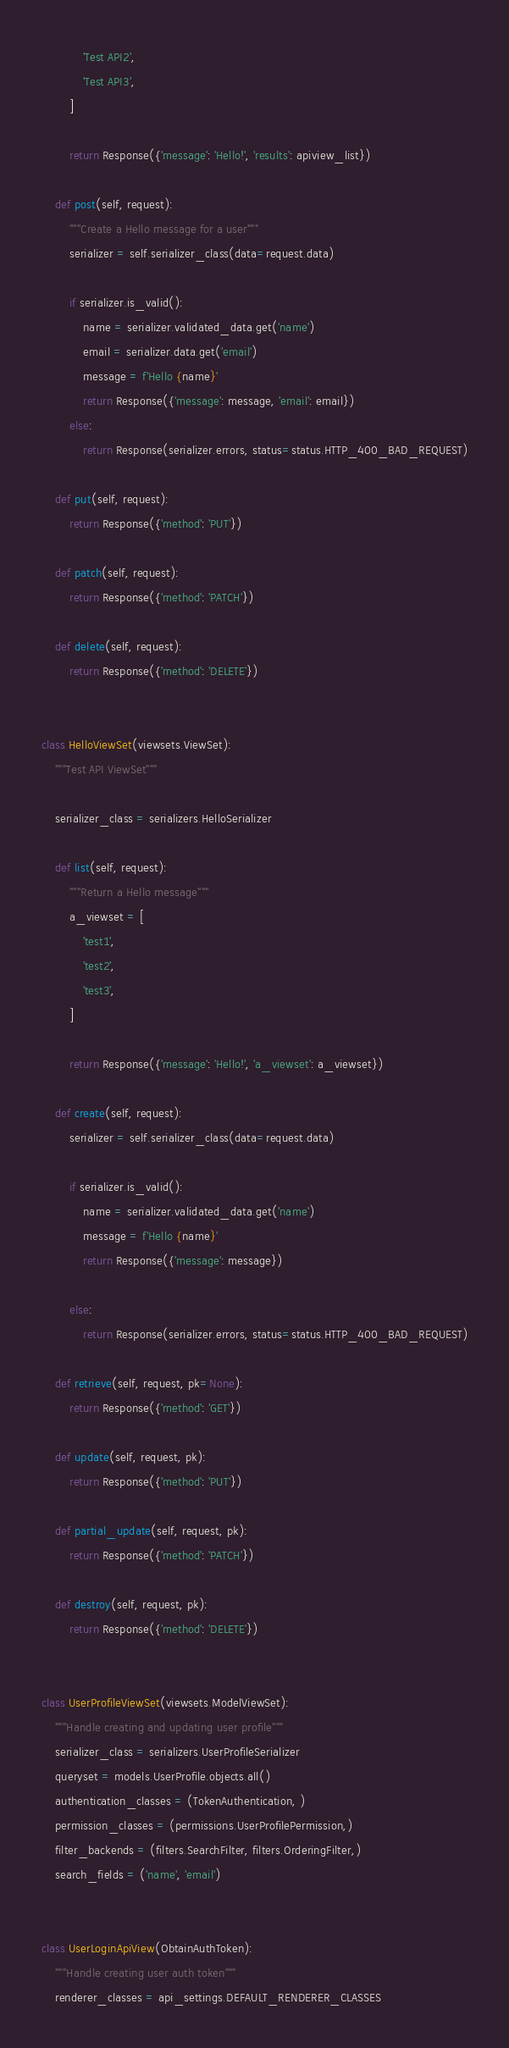<code> <loc_0><loc_0><loc_500><loc_500><_Python_>            'Test API2',
            'Test API3',
        ]

        return Response({'message': 'Hello!', 'results': apiview_list})

    def post(self, request):
        """Create a Hello message for a user"""
        serializer = self.serializer_class(data=request.data)

        if serializer.is_valid():
            name = serializer.validated_data.get('name')
            email = serializer.data.get('email')
            message = f'Hello {name}'
            return Response({'message': message, 'email': email})
        else:
            return Response(serializer.errors, status=status.HTTP_400_BAD_REQUEST)
    
    def put(self, request):
        return Response({'method': 'PUT'})

    def patch(self, request):
        return Response({'method': 'PATCH'})

    def delete(self, request):
        return Response({'method': 'DELETE'})
        

class HelloViewSet(viewsets.ViewSet):
    """Test API ViewSet"""

    serializer_class = serializers.HelloSerializer

    def list(self, request):
        """Return a Hello message"""
        a_viewset = [
            'test1',
            'test2',
            'test3',
        ]

        return Response({'message': 'Hello!', 'a_viewset': a_viewset})
    
    def create(self, request):
        serializer = self.serializer_class(data=request.data)

        if serializer.is_valid():
            name = serializer.validated_data.get('name')
            message = f'Hello {name}'
            return Response({'message': message})
        
        else:
            return Response(serializer.errors, status=status.HTTP_400_BAD_REQUEST)

    def retrieve(self, request, pk=None):
        return Response({'method': 'GET'})

    def update(self, request, pk):
        return Response({'method': 'PUT'})

    def partial_update(self, request, pk):
        return Response({'method': 'PATCH'})

    def destroy(self, request, pk):
        return Response({'method': 'DELETE'})


class UserProfileViewSet(viewsets.ModelViewSet):
    """Handle creating and updating user profile"""
    serializer_class = serializers.UserProfileSerializer
    queryset = models.UserProfile.objects.all()
    authentication_classes = (TokenAuthentication, )
    permission_classes = (permissions.UserProfilePermission,)
    filter_backends = (filters.SearchFilter, filters.OrderingFilter,)
    search_fields = ('name', 'email')


class UserLoginApiView(ObtainAuthToken):
    """Handle creating user auth token"""
    renderer_classes = api_settings.DEFAULT_RENDERER_CLASSES</code> 